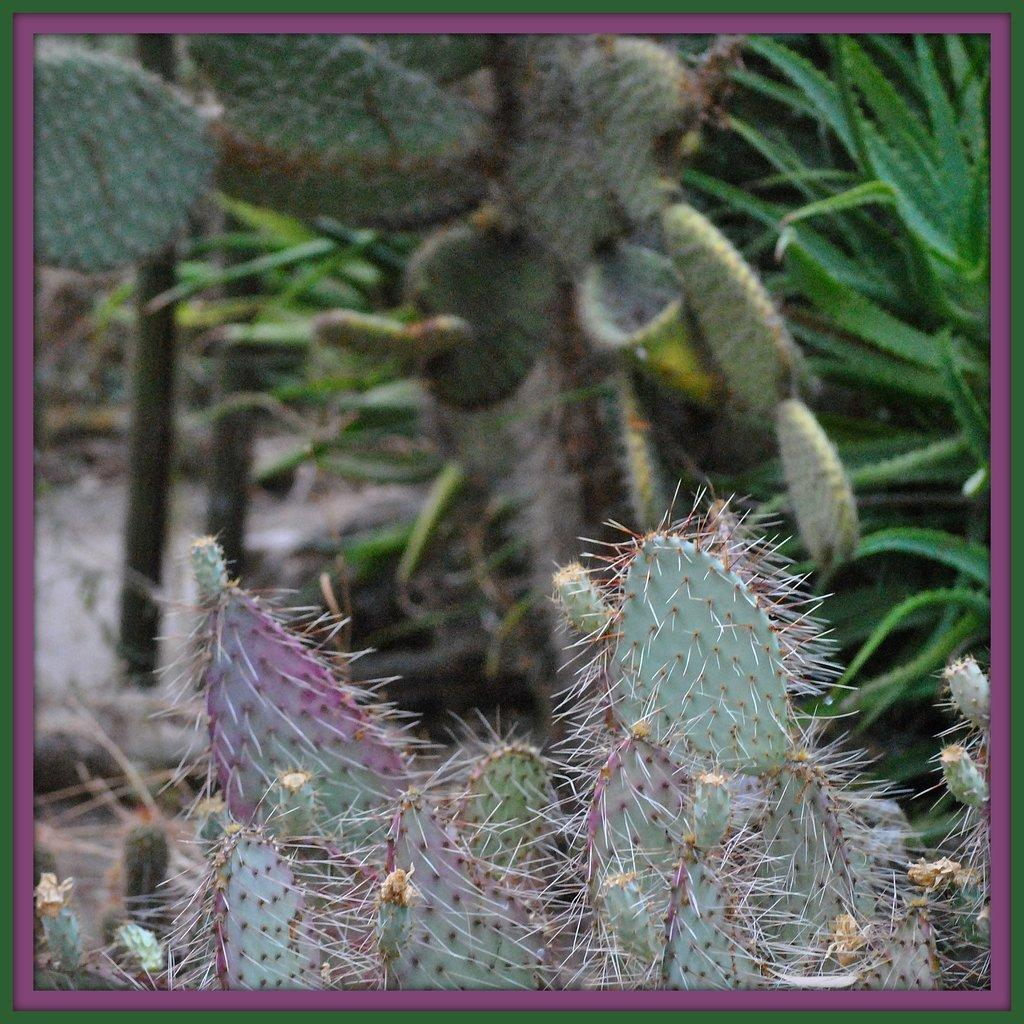What type of plants are visible in the image? There are cactus plants in the image. Can you describe the background of the image? There are plants in the background of the image. How does the cactus push the bed in the image? There is no bed present in the image, and cactus plants do not have the ability to push objects. 